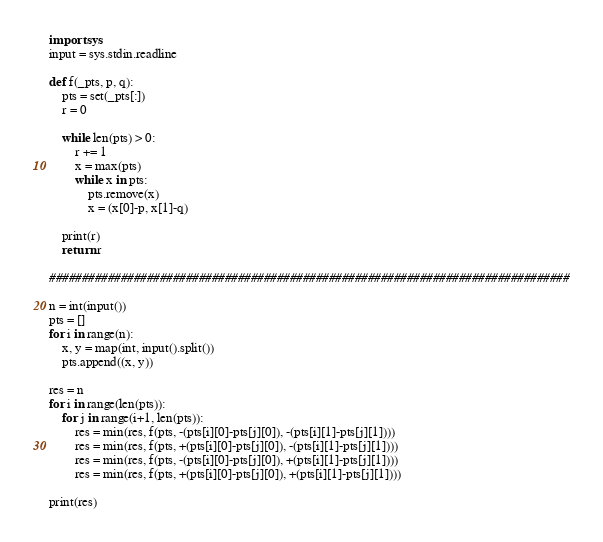Convert code to text. <code><loc_0><loc_0><loc_500><loc_500><_Python_>import sys
input = sys.stdin.readline

def f(_pts, p, q):
    pts = set(_pts[:])
    r = 0

    while len(pts) > 0:
        r += 1
        x = max(pts)
        while x in pts:
            pts.remove(x)
            x = (x[0]-p, x[1]-q)

    print(r)
    return r

################################################################################

n = int(input())
pts = []
for i in range(n):
    x, y = map(int, input().split())
    pts.append((x, y))

res = n
for i in range(len(pts)):
    for j in range(i+1, len(pts)):
        res = min(res, f(pts, -(pts[i][0]-pts[j][0]), -(pts[i][1]-pts[j][1])))
        res = min(res, f(pts, +(pts[i][0]-pts[j][0]), -(pts[i][1]-pts[j][1])))
        res = min(res, f(pts, -(pts[i][0]-pts[j][0]), +(pts[i][1]-pts[j][1])))
        res = min(res, f(pts, +(pts[i][0]-pts[j][0]), +(pts[i][1]-pts[j][1])))

print(res)</code> 